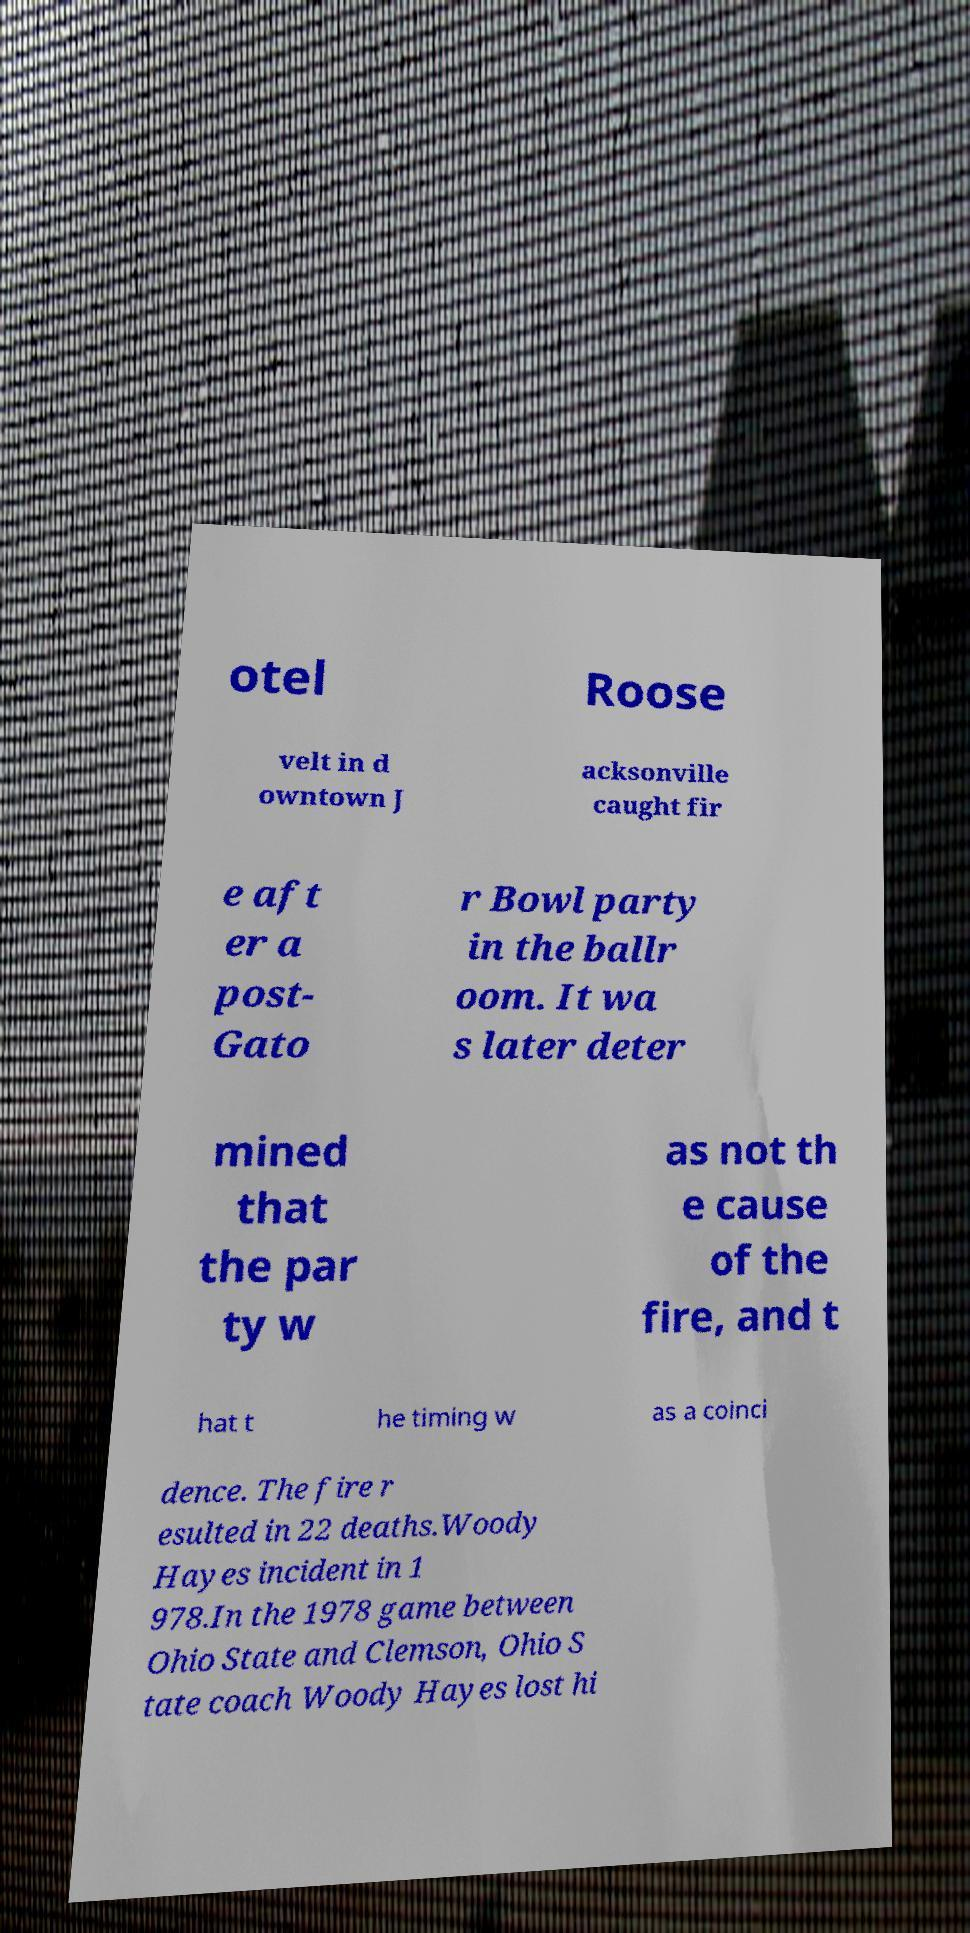There's text embedded in this image that I need extracted. Can you transcribe it verbatim? otel Roose velt in d owntown J acksonville caught fir e aft er a post- Gato r Bowl party in the ballr oom. It wa s later deter mined that the par ty w as not th e cause of the fire, and t hat t he timing w as a coinci dence. The fire r esulted in 22 deaths.Woody Hayes incident in 1 978.In the 1978 game between Ohio State and Clemson, Ohio S tate coach Woody Hayes lost hi 